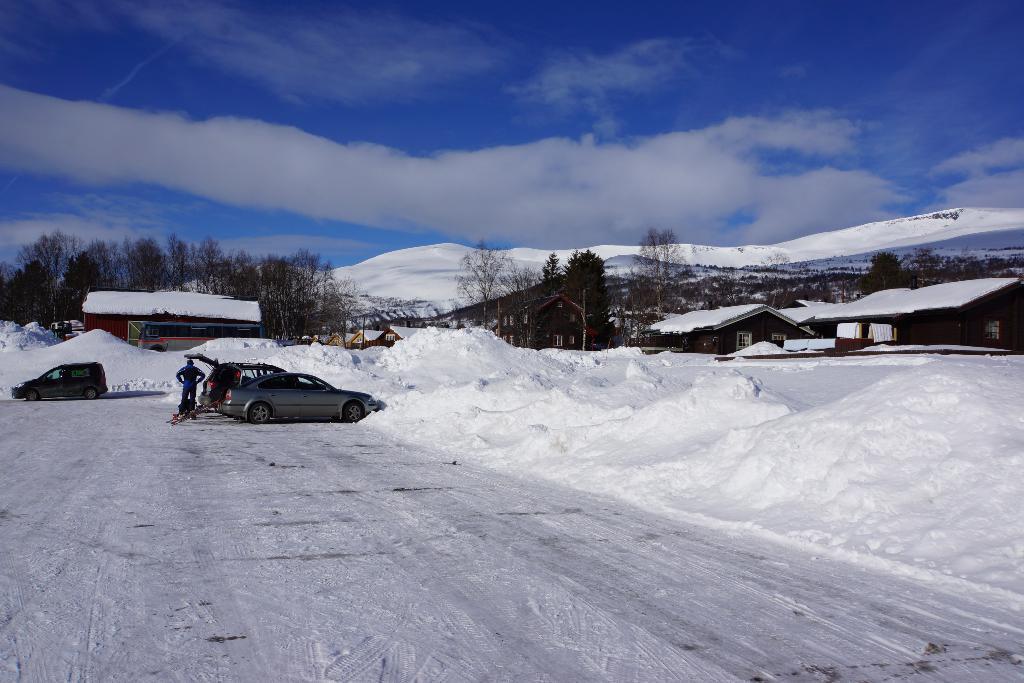Describe this image in one or two sentences. In this image I can see few vehicles and I can also see the person standing. In the background I can see few houses covered with snow, few trees in green color and the sky is in blue and white color. 